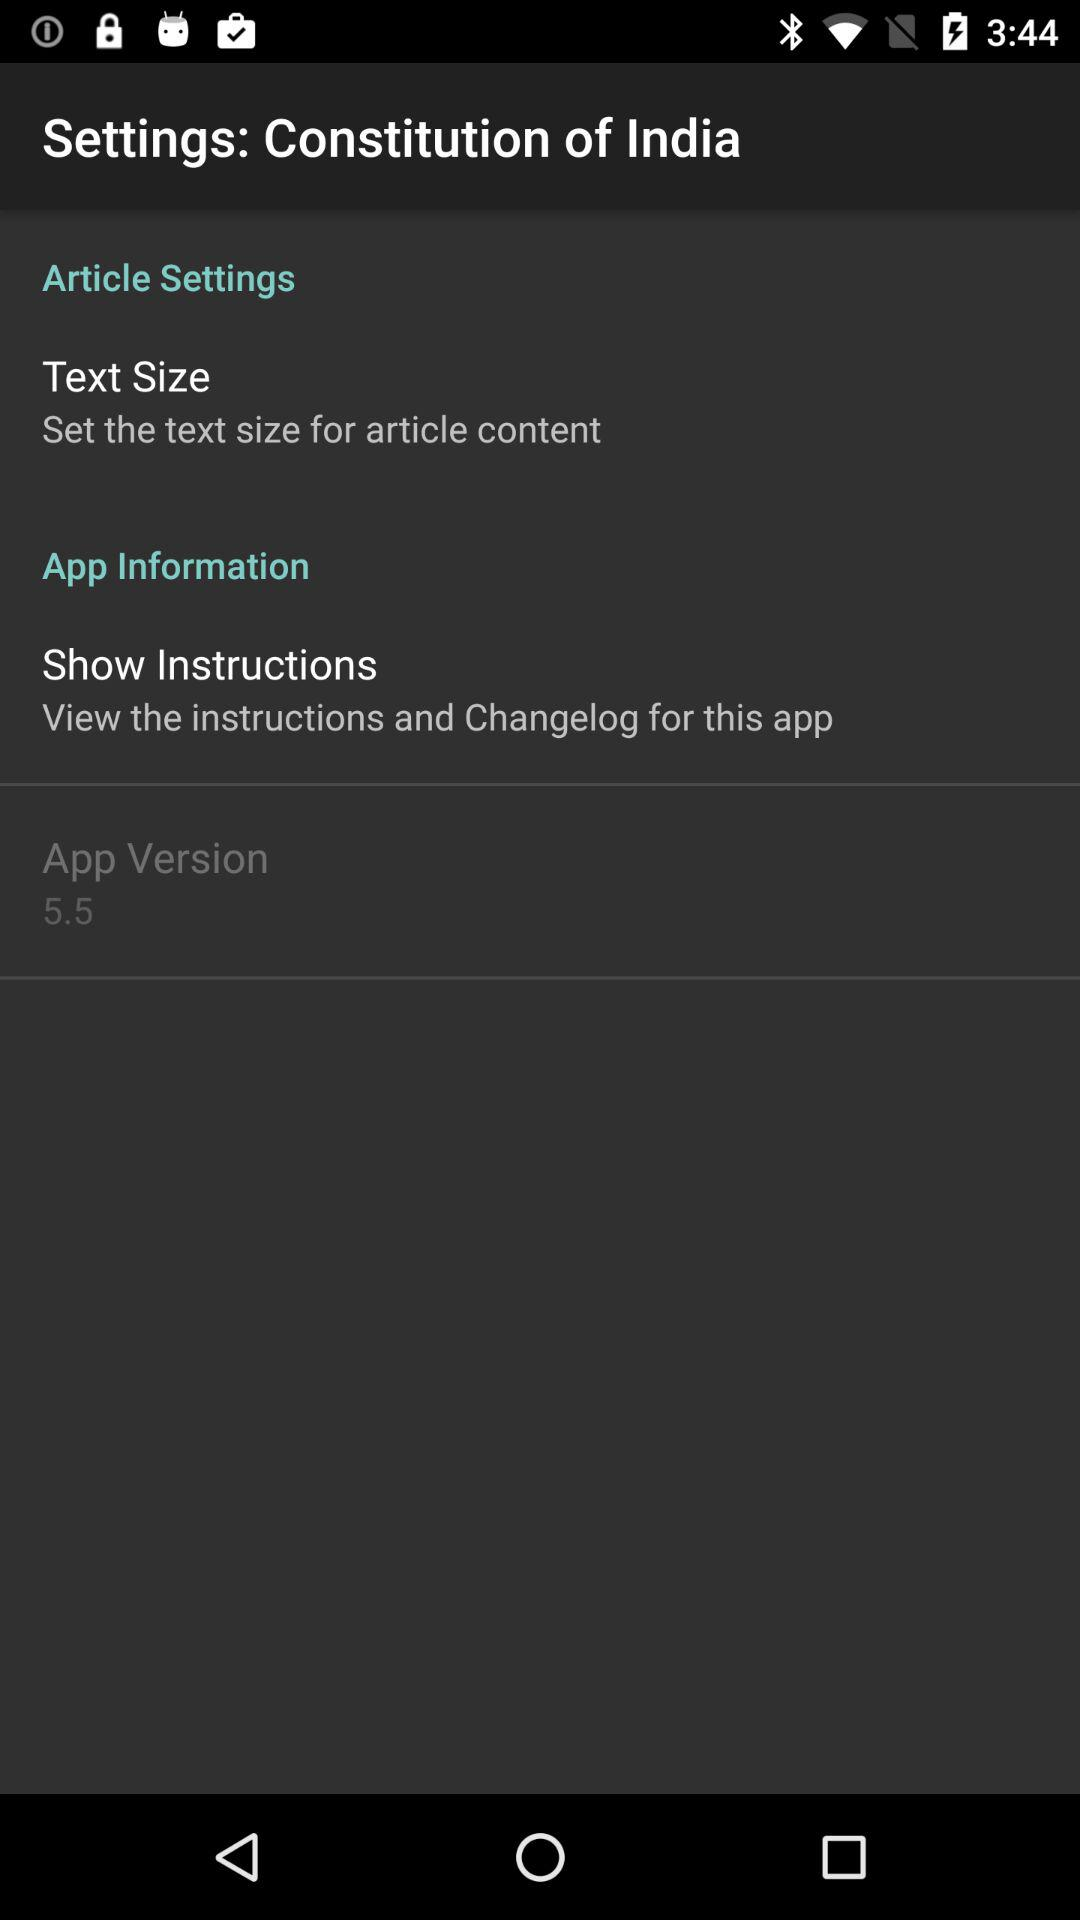How many more items are in the Article Settings section than the App Information section?
Answer the question using a single word or phrase. 1 